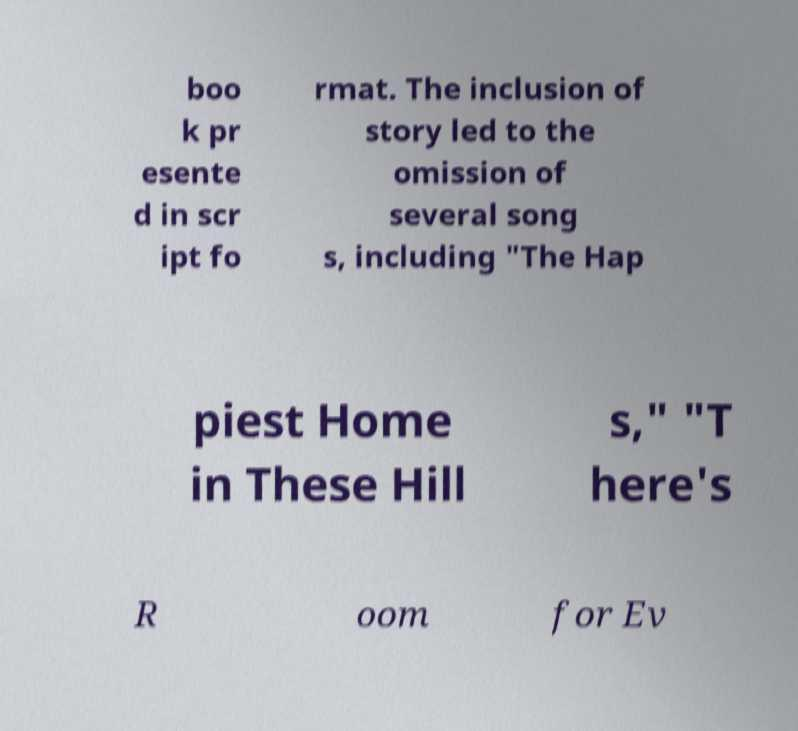Could you extract and type out the text from this image? boo k pr esente d in scr ipt fo rmat. The inclusion of story led to the omission of several song s, including "The Hap piest Home in These Hill s," "T here's R oom for Ev 